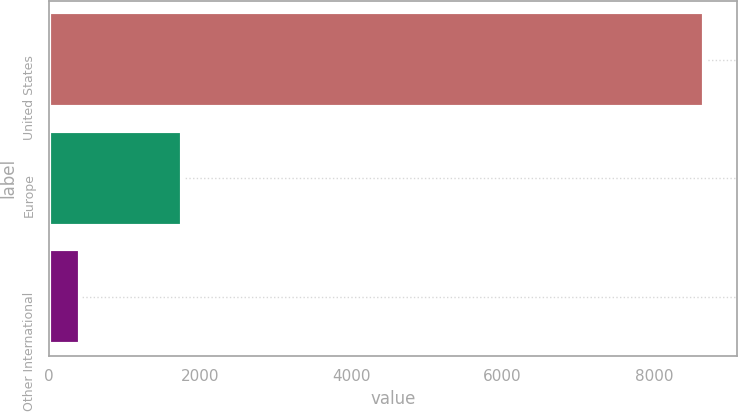<chart> <loc_0><loc_0><loc_500><loc_500><bar_chart><fcel>United States<fcel>Europe<fcel>Other International<nl><fcel>8665<fcel>1756<fcel>406<nl></chart> 